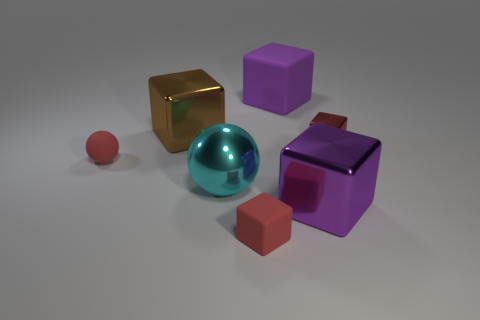There is a tiny thing on the left side of the tiny red block that is left of the red block that is right of the big matte block; what is it made of?
Your answer should be compact. Rubber. Do the purple metallic object and the red thing that is in front of the big cyan metallic object have the same shape?
Make the answer very short. Yes. What number of objects are either red things in front of the tiny red metal object or purple metal objects?
Keep it short and to the point. 3. Is there anything else that is made of the same material as the brown thing?
Keep it short and to the point. Yes. How many cubes are both in front of the big brown thing and to the left of the large matte object?
Ensure brevity in your answer.  1. What number of things are big purple cubes in front of the tiny metallic object or matte blocks on the right side of the small red rubber cube?
Your answer should be very brief. 2. How many other things are there of the same shape as the large purple shiny object?
Provide a succinct answer. 4. There is a big block that is in front of the brown cube; is it the same color as the tiny metal cube?
Provide a short and direct response. No. What number of other things are there of the same size as the purple shiny block?
Your answer should be compact. 3. Do the large cyan object and the brown block have the same material?
Keep it short and to the point. Yes. 